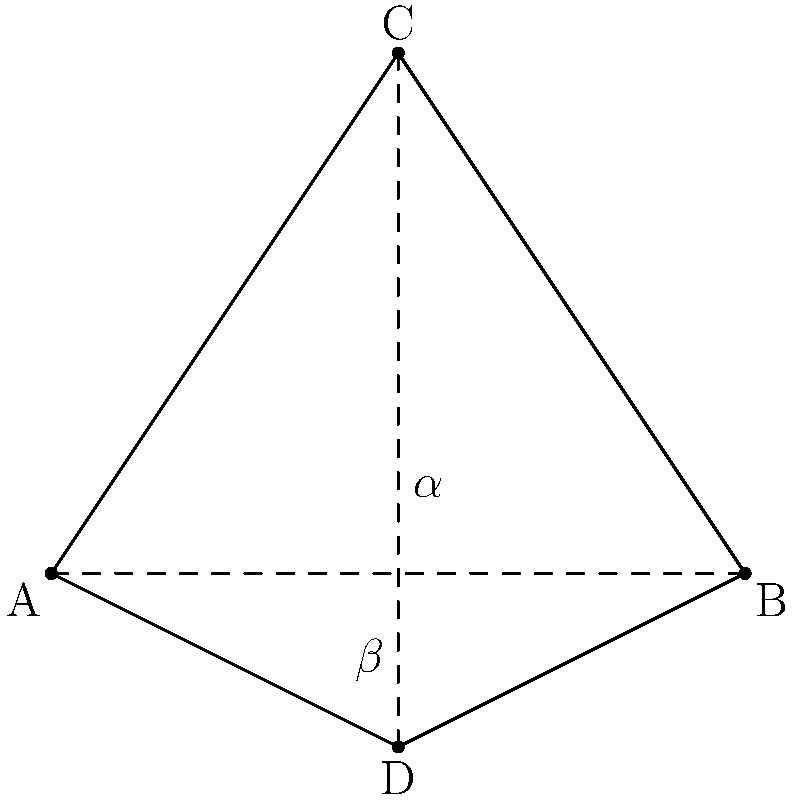In a traditional Guaraní textile pattern, two lines intersect to form a rhombus shape, as shown in the diagram. If the angle $\alpha$ is 60°, what is the measure of angle $\beta$? Let's approach this step-by-step:

1) In a rhombus, opposite angles are congruent. This means that the angle at point A is equal to the angle at point C, and the angle at point B is equal to the angle at point D.

2) The sum of the angles in a quadrilateral is always 360°.

3) In this rhombus, we can see that there are four angles: two $\alpha$ angles and two $\beta$ angles.

4) We can express this as an equation:
   $2\alpha + 2\beta = 360°$

5) We're given that $\alpha = 60°$. Let's substitute this:
   $2(60°) + 2\beta = 360°$
   $120° + 2\beta = 360°$

6) Subtract 120° from both sides:
   $2\beta = 240°$

7) Divide both sides by 2:
   $\beta = 120°$

Therefore, the measure of angle $\beta$ is 120°.
Answer: 120° 